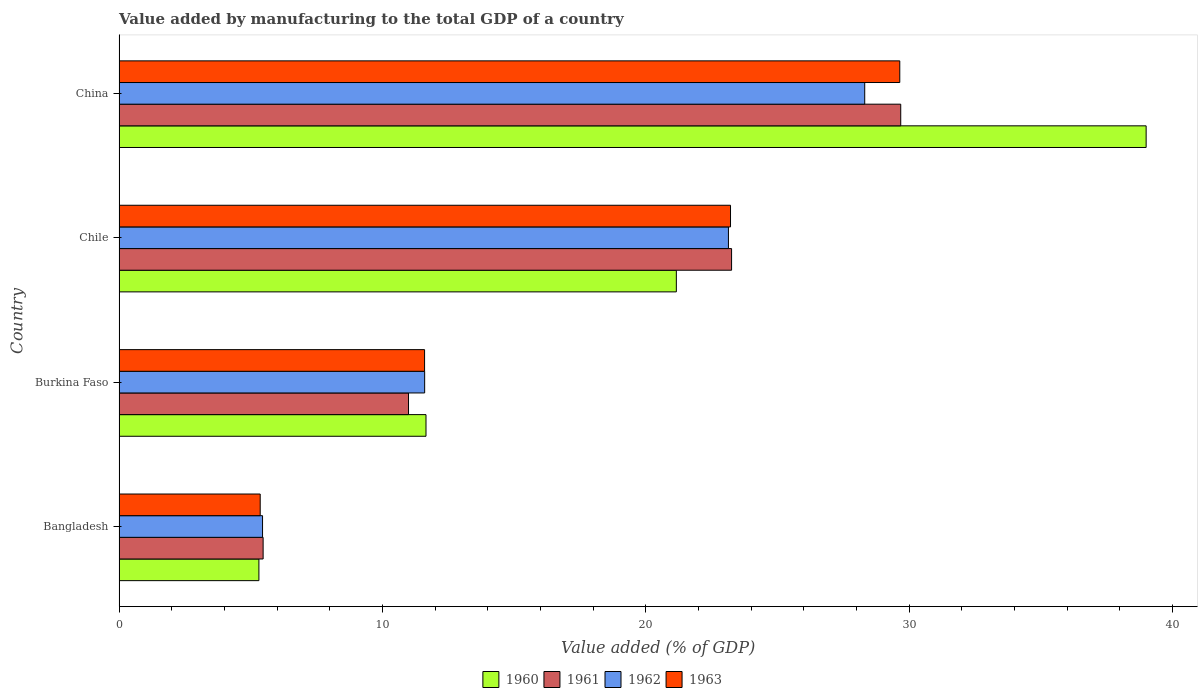Are the number of bars per tick equal to the number of legend labels?
Ensure brevity in your answer.  Yes. How many bars are there on the 2nd tick from the top?
Make the answer very short. 4. How many bars are there on the 4th tick from the bottom?
Provide a succinct answer. 4. In how many cases, is the number of bars for a given country not equal to the number of legend labels?
Keep it short and to the point. 0. What is the value added by manufacturing to the total GDP in 1962 in China?
Your response must be concise. 28.31. Across all countries, what is the maximum value added by manufacturing to the total GDP in 1961?
Offer a terse response. 29.68. Across all countries, what is the minimum value added by manufacturing to the total GDP in 1962?
Offer a terse response. 5.45. In which country was the value added by manufacturing to the total GDP in 1963 maximum?
Your answer should be compact. China. In which country was the value added by manufacturing to the total GDP in 1960 minimum?
Offer a very short reply. Bangladesh. What is the total value added by manufacturing to the total GDP in 1960 in the graph?
Keep it short and to the point. 77.12. What is the difference between the value added by manufacturing to the total GDP in 1961 in Bangladesh and that in China?
Give a very brief answer. -24.21. What is the difference between the value added by manufacturing to the total GDP in 1960 in Bangladesh and the value added by manufacturing to the total GDP in 1963 in Burkina Faso?
Provide a succinct answer. -6.29. What is the average value added by manufacturing to the total GDP in 1960 per country?
Ensure brevity in your answer.  19.28. What is the difference between the value added by manufacturing to the total GDP in 1963 and value added by manufacturing to the total GDP in 1962 in Burkina Faso?
Your answer should be compact. -0. In how many countries, is the value added by manufacturing to the total GDP in 1961 greater than 10 %?
Your answer should be compact. 3. What is the ratio of the value added by manufacturing to the total GDP in 1961 in Burkina Faso to that in China?
Ensure brevity in your answer.  0.37. Is the value added by manufacturing to the total GDP in 1961 in Burkina Faso less than that in China?
Keep it short and to the point. Yes. What is the difference between the highest and the second highest value added by manufacturing to the total GDP in 1960?
Provide a short and direct response. 17.84. What is the difference between the highest and the lowest value added by manufacturing to the total GDP in 1962?
Provide a short and direct response. 22.86. Is it the case that in every country, the sum of the value added by manufacturing to the total GDP in 1963 and value added by manufacturing to the total GDP in 1962 is greater than the sum of value added by manufacturing to the total GDP in 1960 and value added by manufacturing to the total GDP in 1961?
Keep it short and to the point. No. What does the 1st bar from the bottom in Chile represents?
Provide a short and direct response. 1960. How many bars are there?
Make the answer very short. 16. Does the graph contain any zero values?
Keep it short and to the point. No. Where does the legend appear in the graph?
Provide a short and direct response. Bottom center. How many legend labels are there?
Provide a short and direct response. 4. What is the title of the graph?
Make the answer very short. Value added by manufacturing to the total GDP of a country. Does "1974" appear as one of the legend labels in the graph?
Keep it short and to the point. No. What is the label or title of the X-axis?
Make the answer very short. Value added (% of GDP). What is the label or title of the Y-axis?
Your answer should be very brief. Country. What is the Value added (% of GDP) of 1960 in Bangladesh?
Your answer should be compact. 5.31. What is the Value added (% of GDP) of 1961 in Bangladesh?
Give a very brief answer. 5.47. What is the Value added (% of GDP) in 1962 in Bangladesh?
Your answer should be very brief. 5.45. What is the Value added (% of GDP) in 1963 in Bangladesh?
Keep it short and to the point. 5.36. What is the Value added (% of GDP) in 1960 in Burkina Faso?
Keep it short and to the point. 11.65. What is the Value added (% of GDP) in 1961 in Burkina Faso?
Your answer should be compact. 10.99. What is the Value added (% of GDP) of 1962 in Burkina Faso?
Your response must be concise. 11.6. What is the Value added (% of GDP) in 1963 in Burkina Faso?
Give a very brief answer. 11.6. What is the Value added (% of GDP) of 1960 in Chile?
Provide a short and direct response. 21.16. What is the Value added (% of GDP) of 1961 in Chile?
Your answer should be compact. 23.26. What is the Value added (% of GDP) of 1962 in Chile?
Provide a succinct answer. 23.14. What is the Value added (% of GDP) of 1963 in Chile?
Your answer should be very brief. 23.22. What is the Value added (% of GDP) in 1960 in China?
Provide a short and direct response. 39. What is the Value added (% of GDP) in 1961 in China?
Your response must be concise. 29.68. What is the Value added (% of GDP) of 1962 in China?
Provide a succinct answer. 28.31. What is the Value added (% of GDP) in 1963 in China?
Your answer should be very brief. 29.64. Across all countries, what is the maximum Value added (% of GDP) in 1960?
Offer a terse response. 39. Across all countries, what is the maximum Value added (% of GDP) in 1961?
Make the answer very short. 29.68. Across all countries, what is the maximum Value added (% of GDP) in 1962?
Provide a short and direct response. 28.31. Across all countries, what is the maximum Value added (% of GDP) of 1963?
Your answer should be compact. 29.64. Across all countries, what is the minimum Value added (% of GDP) in 1960?
Ensure brevity in your answer.  5.31. Across all countries, what is the minimum Value added (% of GDP) of 1961?
Give a very brief answer. 5.47. Across all countries, what is the minimum Value added (% of GDP) of 1962?
Keep it short and to the point. 5.45. Across all countries, what is the minimum Value added (% of GDP) of 1963?
Offer a terse response. 5.36. What is the total Value added (% of GDP) of 1960 in the graph?
Make the answer very short. 77.12. What is the total Value added (% of GDP) of 1961 in the graph?
Your answer should be compact. 69.4. What is the total Value added (% of GDP) in 1962 in the graph?
Provide a short and direct response. 68.5. What is the total Value added (% of GDP) in 1963 in the graph?
Your answer should be very brief. 69.82. What is the difference between the Value added (% of GDP) of 1960 in Bangladesh and that in Burkina Faso?
Your answer should be compact. -6.34. What is the difference between the Value added (% of GDP) of 1961 in Bangladesh and that in Burkina Faso?
Provide a short and direct response. -5.52. What is the difference between the Value added (% of GDP) in 1962 in Bangladesh and that in Burkina Faso?
Provide a succinct answer. -6.16. What is the difference between the Value added (% of GDP) of 1963 in Bangladesh and that in Burkina Faso?
Your answer should be very brief. -6.24. What is the difference between the Value added (% of GDP) of 1960 in Bangladesh and that in Chile?
Provide a short and direct response. -15.85. What is the difference between the Value added (% of GDP) of 1961 in Bangladesh and that in Chile?
Your answer should be very brief. -17.79. What is the difference between the Value added (% of GDP) of 1962 in Bangladesh and that in Chile?
Provide a succinct answer. -17.69. What is the difference between the Value added (% of GDP) in 1963 in Bangladesh and that in Chile?
Your response must be concise. -17.86. What is the difference between the Value added (% of GDP) in 1960 in Bangladesh and that in China?
Ensure brevity in your answer.  -33.69. What is the difference between the Value added (% of GDP) of 1961 in Bangladesh and that in China?
Your answer should be compact. -24.21. What is the difference between the Value added (% of GDP) of 1962 in Bangladesh and that in China?
Provide a short and direct response. -22.86. What is the difference between the Value added (% of GDP) in 1963 in Bangladesh and that in China?
Ensure brevity in your answer.  -24.28. What is the difference between the Value added (% of GDP) in 1960 in Burkina Faso and that in Chile?
Give a very brief answer. -9.51. What is the difference between the Value added (% of GDP) of 1961 in Burkina Faso and that in Chile?
Make the answer very short. -12.27. What is the difference between the Value added (% of GDP) of 1962 in Burkina Faso and that in Chile?
Make the answer very short. -11.53. What is the difference between the Value added (% of GDP) in 1963 in Burkina Faso and that in Chile?
Give a very brief answer. -11.62. What is the difference between the Value added (% of GDP) in 1960 in Burkina Faso and that in China?
Offer a very short reply. -27.34. What is the difference between the Value added (% of GDP) of 1961 in Burkina Faso and that in China?
Keep it short and to the point. -18.69. What is the difference between the Value added (% of GDP) in 1962 in Burkina Faso and that in China?
Your answer should be compact. -16.71. What is the difference between the Value added (% of GDP) of 1963 in Burkina Faso and that in China?
Your answer should be compact. -18.04. What is the difference between the Value added (% of GDP) of 1960 in Chile and that in China?
Provide a short and direct response. -17.84. What is the difference between the Value added (% of GDP) in 1961 in Chile and that in China?
Offer a terse response. -6.42. What is the difference between the Value added (% of GDP) of 1962 in Chile and that in China?
Your answer should be very brief. -5.17. What is the difference between the Value added (% of GDP) of 1963 in Chile and that in China?
Your response must be concise. -6.43. What is the difference between the Value added (% of GDP) in 1960 in Bangladesh and the Value added (% of GDP) in 1961 in Burkina Faso?
Offer a terse response. -5.68. What is the difference between the Value added (% of GDP) of 1960 in Bangladesh and the Value added (% of GDP) of 1962 in Burkina Faso?
Make the answer very short. -6.29. What is the difference between the Value added (% of GDP) of 1960 in Bangladesh and the Value added (% of GDP) of 1963 in Burkina Faso?
Provide a succinct answer. -6.29. What is the difference between the Value added (% of GDP) in 1961 in Bangladesh and the Value added (% of GDP) in 1962 in Burkina Faso?
Offer a very short reply. -6.13. What is the difference between the Value added (% of GDP) of 1961 in Bangladesh and the Value added (% of GDP) of 1963 in Burkina Faso?
Give a very brief answer. -6.13. What is the difference between the Value added (% of GDP) of 1962 in Bangladesh and the Value added (% of GDP) of 1963 in Burkina Faso?
Offer a terse response. -6.15. What is the difference between the Value added (% of GDP) in 1960 in Bangladesh and the Value added (% of GDP) in 1961 in Chile?
Ensure brevity in your answer.  -17.95. What is the difference between the Value added (% of GDP) of 1960 in Bangladesh and the Value added (% of GDP) of 1962 in Chile?
Offer a very short reply. -17.83. What is the difference between the Value added (% of GDP) in 1960 in Bangladesh and the Value added (% of GDP) in 1963 in Chile?
Offer a very short reply. -17.91. What is the difference between the Value added (% of GDP) of 1961 in Bangladesh and the Value added (% of GDP) of 1962 in Chile?
Offer a terse response. -17.67. What is the difference between the Value added (% of GDP) of 1961 in Bangladesh and the Value added (% of GDP) of 1963 in Chile?
Provide a short and direct response. -17.75. What is the difference between the Value added (% of GDP) in 1962 in Bangladesh and the Value added (% of GDP) in 1963 in Chile?
Keep it short and to the point. -17.77. What is the difference between the Value added (% of GDP) of 1960 in Bangladesh and the Value added (% of GDP) of 1961 in China?
Give a very brief answer. -24.37. What is the difference between the Value added (% of GDP) of 1960 in Bangladesh and the Value added (% of GDP) of 1962 in China?
Your response must be concise. -23. What is the difference between the Value added (% of GDP) in 1960 in Bangladesh and the Value added (% of GDP) in 1963 in China?
Offer a terse response. -24.33. What is the difference between the Value added (% of GDP) in 1961 in Bangladesh and the Value added (% of GDP) in 1962 in China?
Keep it short and to the point. -22.84. What is the difference between the Value added (% of GDP) of 1961 in Bangladesh and the Value added (% of GDP) of 1963 in China?
Ensure brevity in your answer.  -24.17. What is the difference between the Value added (% of GDP) of 1962 in Bangladesh and the Value added (% of GDP) of 1963 in China?
Your response must be concise. -24.2. What is the difference between the Value added (% of GDP) of 1960 in Burkina Faso and the Value added (% of GDP) of 1961 in Chile?
Offer a terse response. -11.6. What is the difference between the Value added (% of GDP) of 1960 in Burkina Faso and the Value added (% of GDP) of 1962 in Chile?
Give a very brief answer. -11.48. What is the difference between the Value added (% of GDP) in 1960 in Burkina Faso and the Value added (% of GDP) in 1963 in Chile?
Your answer should be very brief. -11.56. What is the difference between the Value added (% of GDP) of 1961 in Burkina Faso and the Value added (% of GDP) of 1962 in Chile?
Provide a short and direct response. -12.15. What is the difference between the Value added (% of GDP) in 1961 in Burkina Faso and the Value added (% of GDP) in 1963 in Chile?
Offer a very short reply. -12.23. What is the difference between the Value added (% of GDP) in 1962 in Burkina Faso and the Value added (% of GDP) in 1963 in Chile?
Ensure brevity in your answer.  -11.61. What is the difference between the Value added (% of GDP) in 1960 in Burkina Faso and the Value added (% of GDP) in 1961 in China?
Make the answer very short. -18.03. What is the difference between the Value added (% of GDP) of 1960 in Burkina Faso and the Value added (% of GDP) of 1962 in China?
Provide a short and direct response. -16.66. What is the difference between the Value added (% of GDP) in 1960 in Burkina Faso and the Value added (% of GDP) in 1963 in China?
Offer a very short reply. -17.99. What is the difference between the Value added (% of GDP) in 1961 in Burkina Faso and the Value added (% of GDP) in 1962 in China?
Ensure brevity in your answer.  -17.32. What is the difference between the Value added (% of GDP) in 1961 in Burkina Faso and the Value added (% of GDP) in 1963 in China?
Provide a succinct answer. -18.65. What is the difference between the Value added (% of GDP) in 1962 in Burkina Faso and the Value added (% of GDP) in 1963 in China?
Ensure brevity in your answer.  -18.04. What is the difference between the Value added (% of GDP) of 1960 in Chile and the Value added (% of GDP) of 1961 in China?
Provide a short and direct response. -8.52. What is the difference between the Value added (% of GDP) of 1960 in Chile and the Value added (% of GDP) of 1962 in China?
Give a very brief answer. -7.15. What is the difference between the Value added (% of GDP) in 1960 in Chile and the Value added (% of GDP) in 1963 in China?
Keep it short and to the point. -8.48. What is the difference between the Value added (% of GDP) in 1961 in Chile and the Value added (% of GDP) in 1962 in China?
Keep it short and to the point. -5.06. What is the difference between the Value added (% of GDP) in 1961 in Chile and the Value added (% of GDP) in 1963 in China?
Offer a terse response. -6.39. What is the difference between the Value added (% of GDP) of 1962 in Chile and the Value added (% of GDP) of 1963 in China?
Provide a short and direct response. -6.51. What is the average Value added (% of GDP) in 1960 per country?
Give a very brief answer. 19.28. What is the average Value added (% of GDP) of 1961 per country?
Provide a short and direct response. 17.35. What is the average Value added (% of GDP) of 1962 per country?
Offer a terse response. 17.13. What is the average Value added (% of GDP) of 1963 per country?
Provide a short and direct response. 17.46. What is the difference between the Value added (% of GDP) in 1960 and Value added (% of GDP) in 1961 in Bangladesh?
Offer a terse response. -0.16. What is the difference between the Value added (% of GDP) of 1960 and Value added (% of GDP) of 1962 in Bangladesh?
Offer a terse response. -0.14. What is the difference between the Value added (% of GDP) in 1960 and Value added (% of GDP) in 1963 in Bangladesh?
Make the answer very short. -0.05. What is the difference between the Value added (% of GDP) of 1961 and Value added (% of GDP) of 1962 in Bangladesh?
Keep it short and to the point. 0.02. What is the difference between the Value added (% of GDP) in 1961 and Value added (% of GDP) in 1963 in Bangladesh?
Your answer should be very brief. 0.11. What is the difference between the Value added (% of GDP) in 1962 and Value added (% of GDP) in 1963 in Bangladesh?
Ensure brevity in your answer.  0.09. What is the difference between the Value added (% of GDP) in 1960 and Value added (% of GDP) in 1961 in Burkina Faso?
Provide a succinct answer. 0.66. What is the difference between the Value added (% of GDP) in 1960 and Value added (% of GDP) in 1962 in Burkina Faso?
Your response must be concise. 0.05. What is the difference between the Value added (% of GDP) in 1960 and Value added (% of GDP) in 1963 in Burkina Faso?
Give a very brief answer. 0.05. What is the difference between the Value added (% of GDP) in 1961 and Value added (% of GDP) in 1962 in Burkina Faso?
Provide a succinct answer. -0.61. What is the difference between the Value added (% of GDP) of 1961 and Value added (% of GDP) of 1963 in Burkina Faso?
Keep it short and to the point. -0.61. What is the difference between the Value added (% of GDP) in 1962 and Value added (% of GDP) in 1963 in Burkina Faso?
Your response must be concise. 0. What is the difference between the Value added (% of GDP) of 1960 and Value added (% of GDP) of 1961 in Chile?
Your response must be concise. -2.1. What is the difference between the Value added (% of GDP) of 1960 and Value added (% of GDP) of 1962 in Chile?
Your response must be concise. -1.98. What is the difference between the Value added (% of GDP) in 1960 and Value added (% of GDP) in 1963 in Chile?
Ensure brevity in your answer.  -2.06. What is the difference between the Value added (% of GDP) in 1961 and Value added (% of GDP) in 1962 in Chile?
Your response must be concise. 0.12. What is the difference between the Value added (% of GDP) of 1961 and Value added (% of GDP) of 1963 in Chile?
Ensure brevity in your answer.  0.04. What is the difference between the Value added (% of GDP) of 1962 and Value added (% of GDP) of 1963 in Chile?
Your answer should be very brief. -0.08. What is the difference between the Value added (% of GDP) of 1960 and Value added (% of GDP) of 1961 in China?
Provide a succinct answer. 9.32. What is the difference between the Value added (% of GDP) of 1960 and Value added (% of GDP) of 1962 in China?
Provide a short and direct response. 10.69. What is the difference between the Value added (% of GDP) in 1960 and Value added (% of GDP) in 1963 in China?
Your answer should be compact. 9.35. What is the difference between the Value added (% of GDP) in 1961 and Value added (% of GDP) in 1962 in China?
Offer a very short reply. 1.37. What is the difference between the Value added (% of GDP) of 1961 and Value added (% of GDP) of 1963 in China?
Keep it short and to the point. 0.04. What is the difference between the Value added (% of GDP) of 1962 and Value added (% of GDP) of 1963 in China?
Your answer should be very brief. -1.33. What is the ratio of the Value added (% of GDP) in 1960 in Bangladesh to that in Burkina Faso?
Give a very brief answer. 0.46. What is the ratio of the Value added (% of GDP) of 1961 in Bangladesh to that in Burkina Faso?
Your answer should be compact. 0.5. What is the ratio of the Value added (% of GDP) in 1962 in Bangladesh to that in Burkina Faso?
Offer a terse response. 0.47. What is the ratio of the Value added (% of GDP) of 1963 in Bangladesh to that in Burkina Faso?
Keep it short and to the point. 0.46. What is the ratio of the Value added (% of GDP) of 1960 in Bangladesh to that in Chile?
Provide a succinct answer. 0.25. What is the ratio of the Value added (% of GDP) in 1961 in Bangladesh to that in Chile?
Keep it short and to the point. 0.24. What is the ratio of the Value added (% of GDP) of 1962 in Bangladesh to that in Chile?
Provide a short and direct response. 0.24. What is the ratio of the Value added (% of GDP) in 1963 in Bangladesh to that in Chile?
Make the answer very short. 0.23. What is the ratio of the Value added (% of GDP) in 1960 in Bangladesh to that in China?
Your response must be concise. 0.14. What is the ratio of the Value added (% of GDP) in 1961 in Bangladesh to that in China?
Your response must be concise. 0.18. What is the ratio of the Value added (% of GDP) in 1962 in Bangladesh to that in China?
Keep it short and to the point. 0.19. What is the ratio of the Value added (% of GDP) of 1963 in Bangladesh to that in China?
Your response must be concise. 0.18. What is the ratio of the Value added (% of GDP) in 1960 in Burkina Faso to that in Chile?
Make the answer very short. 0.55. What is the ratio of the Value added (% of GDP) in 1961 in Burkina Faso to that in Chile?
Your answer should be very brief. 0.47. What is the ratio of the Value added (% of GDP) of 1962 in Burkina Faso to that in Chile?
Your answer should be compact. 0.5. What is the ratio of the Value added (% of GDP) of 1963 in Burkina Faso to that in Chile?
Your answer should be compact. 0.5. What is the ratio of the Value added (% of GDP) in 1960 in Burkina Faso to that in China?
Keep it short and to the point. 0.3. What is the ratio of the Value added (% of GDP) in 1961 in Burkina Faso to that in China?
Offer a very short reply. 0.37. What is the ratio of the Value added (% of GDP) of 1962 in Burkina Faso to that in China?
Provide a succinct answer. 0.41. What is the ratio of the Value added (% of GDP) of 1963 in Burkina Faso to that in China?
Your answer should be very brief. 0.39. What is the ratio of the Value added (% of GDP) of 1960 in Chile to that in China?
Your response must be concise. 0.54. What is the ratio of the Value added (% of GDP) in 1961 in Chile to that in China?
Offer a very short reply. 0.78. What is the ratio of the Value added (% of GDP) in 1962 in Chile to that in China?
Offer a terse response. 0.82. What is the ratio of the Value added (% of GDP) in 1963 in Chile to that in China?
Offer a very short reply. 0.78. What is the difference between the highest and the second highest Value added (% of GDP) of 1960?
Give a very brief answer. 17.84. What is the difference between the highest and the second highest Value added (% of GDP) of 1961?
Offer a very short reply. 6.42. What is the difference between the highest and the second highest Value added (% of GDP) of 1962?
Provide a short and direct response. 5.17. What is the difference between the highest and the second highest Value added (% of GDP) of 1963?
Offer a very short reply. 6.43. What is the difference between the highest and the lowest Value added (% of GDP) of 1960?
Provide a short and direct response. 33.69. What is the difference between the highest and the lowest Value added (% of GDP) of 1961?
Provide a succinct answer. 24.21. What is the difference between the highest and the lowest Value added (% of GDP) of 1962?
Give a very brief answer. 22.86. What is the difference between the highest and the lowest Value added (% of GDP) in 1963?
Your response must be concise. 24.28. 